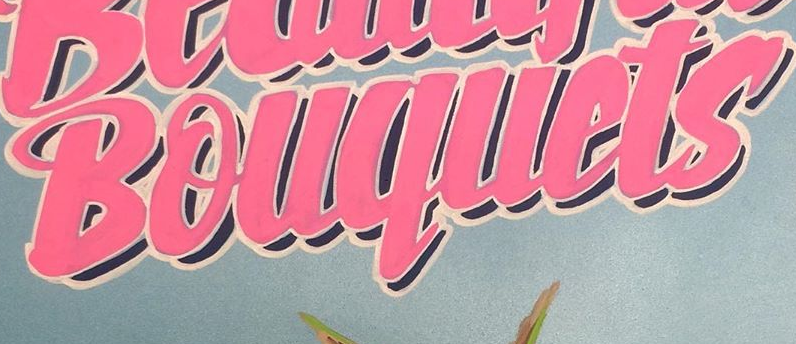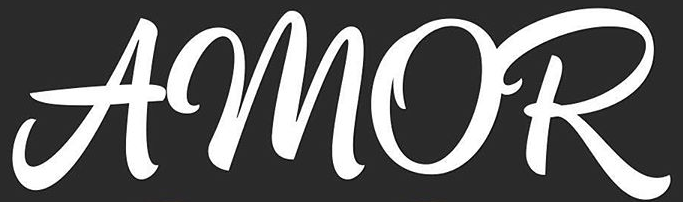What text is displayed in these images sequentially, separated by a semicolon? Bouquets; AMOR 